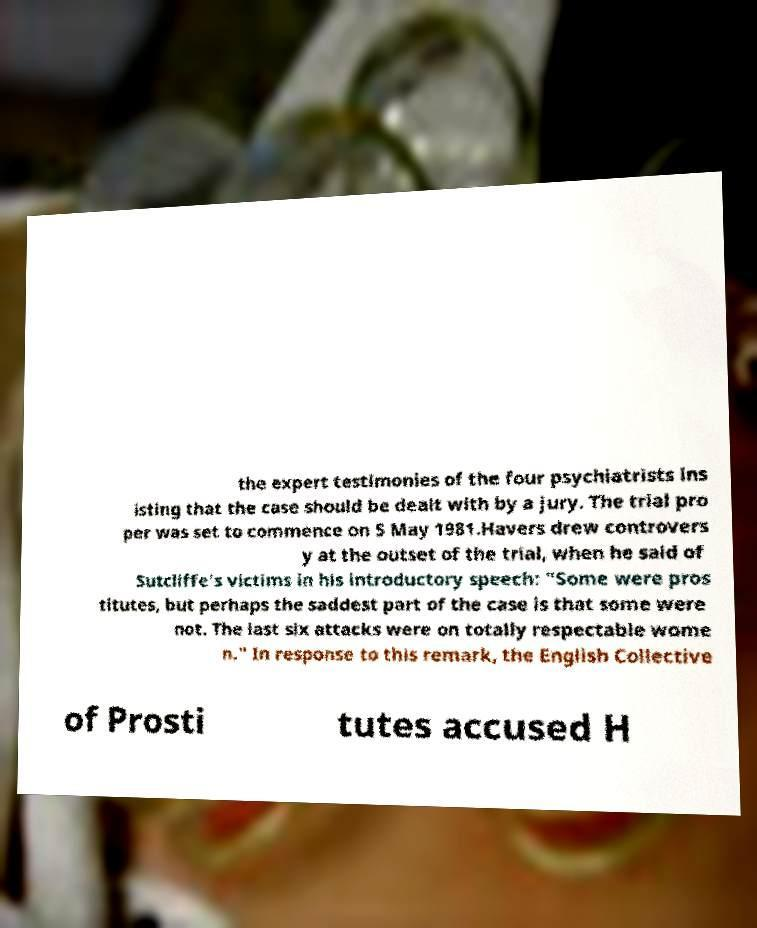I need the written content from this picture converted into text. Can you do that? the expert testimonies of the four psychiatrists ins isting that the case should be dealt with by a jury. The trial pro per was set to commence on 5 May 1981.Havers drew controvers y at the outset of the trial, when he said of Sutcliffe's victims in his introductory speech: "Some were pros titutes, but perhaps the saddest part of the case is that some were not. The last six attacks were on totally respectable wome n." In response to this remark, the English Collective of Prosti tutes accused H 